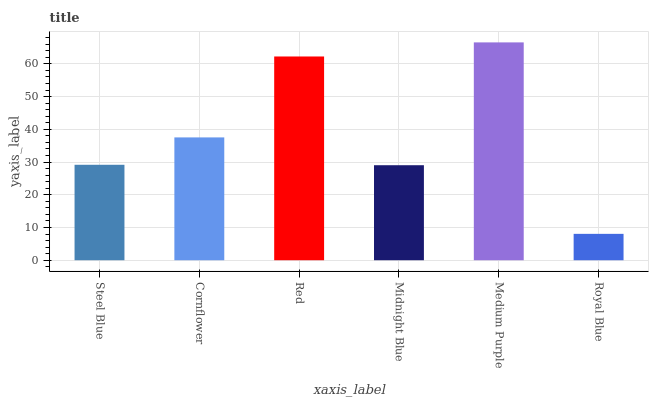Is Cornflower the minimum?
Answer yes or no. No. Is Cornflower the maximum?
Answer yes or no. No. Is Cornflower greater than Steel Blue?
Answer yes or no. Yes. Is Steel Blue less than Cornflower?
Answer yes or no. Yes. Is Steel Blue greater than Cornflower?
Answer yes or no. No. Is Cornflower less than Steel Blue?
Answer yes or no. No. Is Cornflower the high median?
Answer yes or no. Yes. Is Steel Blue the low median?
Answer yes or no. Yes. Is Royal Blue the high median?
Answer yes or no. No. Is Red the low median?
Answer yes or no. No. 